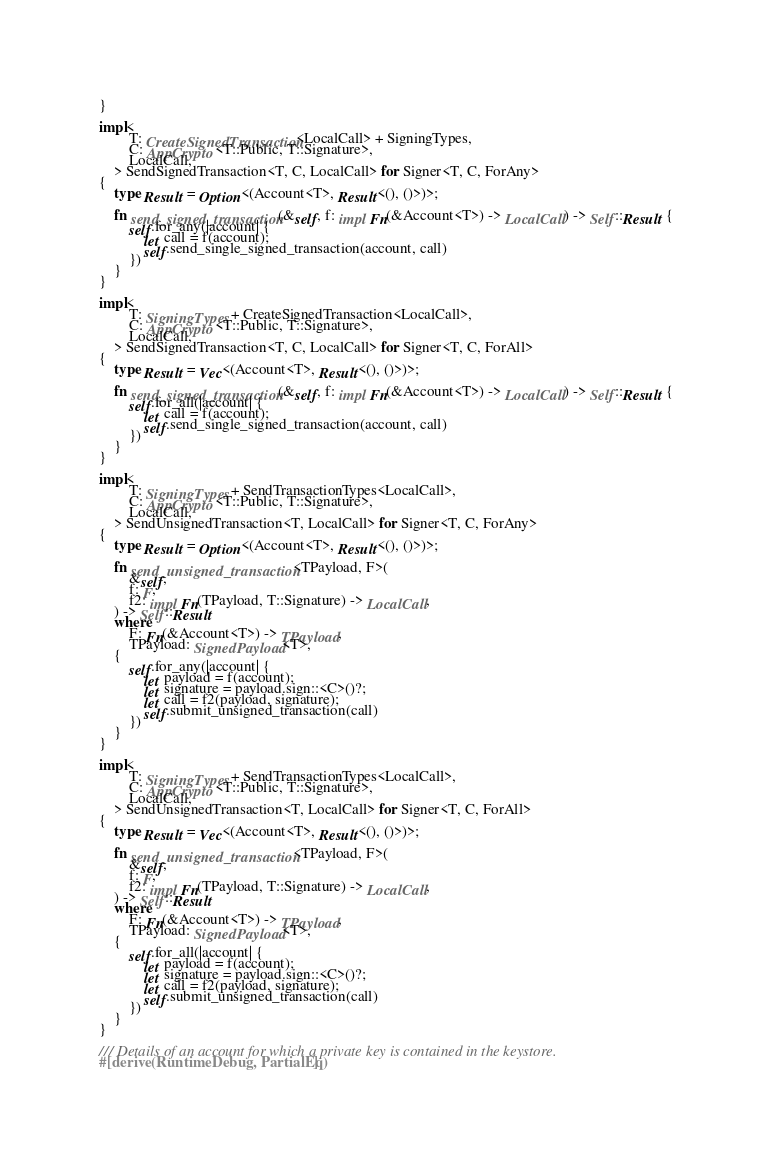Convert code to text. <code><loc_0><loc_0><loc_500><loc_500><_Rust_>}

impl<
		T: CreateSignedTransaction<LocalCall> + SigningTypes,
		C: AppCrypto<T::Public, T::Signature>,
		LocalCall,
	> SendSignedTransaction<T, C, LocalCall> for Signer<T, C, ForAny>
{
	type Result = Option<(Account<T>, Result<(), ()>)>;

	fn send_signed_transaction(&self, f: impl Fn(&Account<T>) -> LocalCall) -> Self::Result {
		self.for_any(|account| {
			let call = f(account);
			self.send_single_signed_transaction(account, call)
		})
	}
}

impl<
		T: SigningTypes + CreateSignedTransaction<LocalCall>,
		C: AppCrypto<T::Public, T::Signature>,
		LocalCall,
	> SendSignedTransaction<T, C, LocalCall> for Signer<T, C, ForAll>
{
	type Result = Vec<(Account<T>, Result<(), ()>)>;

	fn send_signed_transaction(&self, f: impl Fn(&Account<T>) -> LocalCall) -> Self::Result {
		self.for_all(|account| {
			let call = f(account);
			self.send_single_signed_transaction(account, call)
		})
	}
}

impl<
		T: SigningTypes + SendTransactionTypes<LocalCall>,
		C: AppCrypto<T::Public, T::Signature>,
		LocalCall,
	> SendUnsignedTransaction<T, LocalCall> for Signer<T, C, ForAny>
{
	type Result = Option<(Account<T>, Result<(), ()>)>;

	fn send_unsigned_transaction<TPayload, F>(
		&self,
		f: F,
		f2: impl Fn(TPayload, T::Signature) -> LocalCall,
	) -> Self::Result
	where
		F: Fn(&Account<T>) -> TPayload,
		TPayload: SignedPayload<T>,
	{
		self.for_any(|account| {
			let payload = f(account);
			let signature = payload.sign::<C>()?;
			let call = f2(payload, signature);
			self.submit_unsigned_transaction(call)
		})
	}
}

impl<
		T: SigningTypes + SendTransactionTypes<LocalCall>,
		C: AppCrypto<T::Public, T::Signature>,
		LocalCall,
	> SendUnsignedTransaction<T, LocalCall> for Signer<T, C, ForAll>
{
	type Result = Vec<(Account<T>, Result<(), ()>)>;

	fn send_unsigned_transaction<TPayload, F>(
		&self,
		f: F,
		f2: impl Fn(TPayload, T::Signature) -> LocalCall,
	) -> Self::Result
	where
		F: Fn(&Account<T>) -> TPayload,
		TPayload: SignedPayload<T>,
	{
		self.for_all(|account| {
			let payload = f(account);
			let signature = payload.sign::<C>()?;
			let call = f2(payload, signature);
			self.submit_unsigned_transaction(call)
		})
	}
}

/// Details of an account for which a private key is contained in the keystore.
#[derive(RuntimeDebug, PartialEq)]</code> 